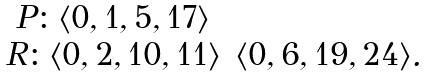Convert formula to latex. <formula><loc_0><loc_0><loc_500><loc_500>\begin{array} { c c c } P \colon \langle 0 , 1 , 5 , 1 7 \rangle \\ R \colon \langle 0 , 2 , 1 0 , 1 1 \rangle & \langle 0 , 6 , 1 9 , 2 4 \rangle . \\ \end{array}</formula> 